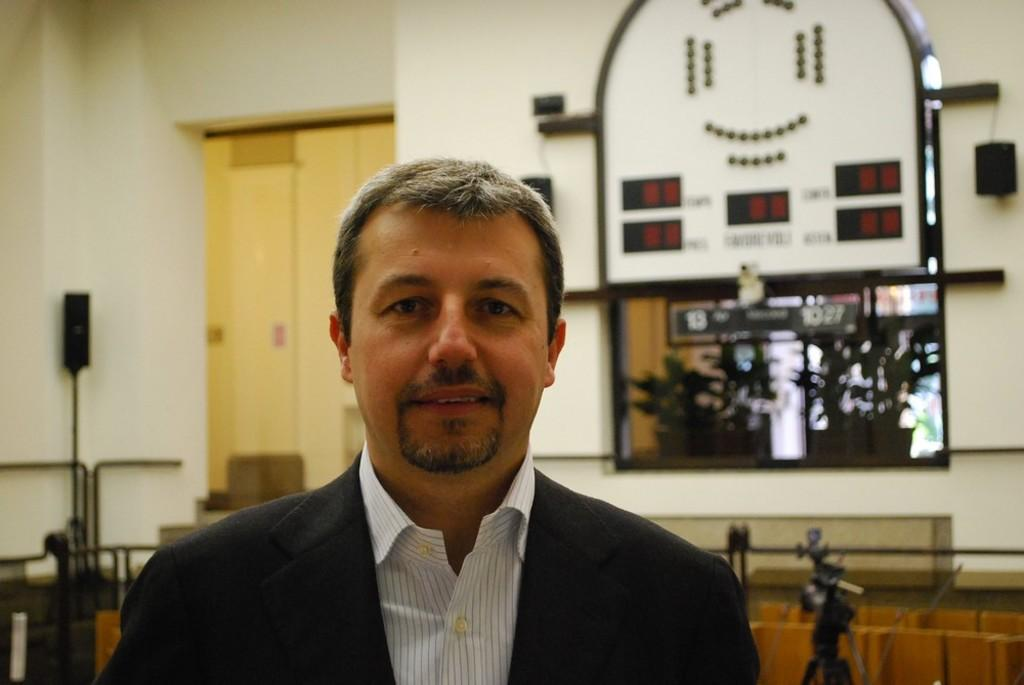What is the main subject in the foreground of the image? There is a man in the foreground of the image. What can be seen behind the man? There are different objects visible behind the man. What is the primary feature in the background of the image? There is a wall in the background of the image. What type of oranges are being suggested as an activity in the image? There are no oranges or suggestions of activities present in the image. 